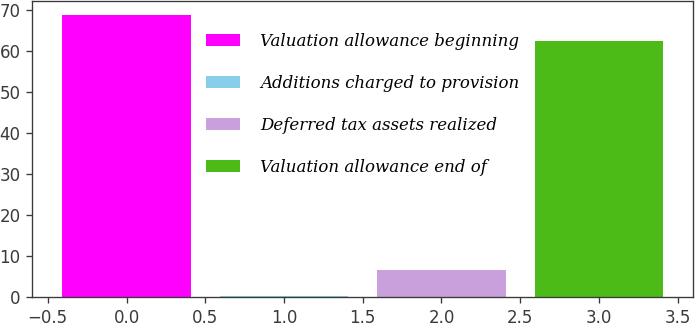Convert chart. <chart><loc_0><loc_0><loc_500><loc_500><bar_chart><fcel>Valuation allowance beginning<fcel>Additions charged to provision<fcel>Deferred tax assets realized<fcel>Valuation allowance end of<nl><fcel>68.64<fcel>0.3<fcel>6.64<fcel>62.3<nl></chart> 